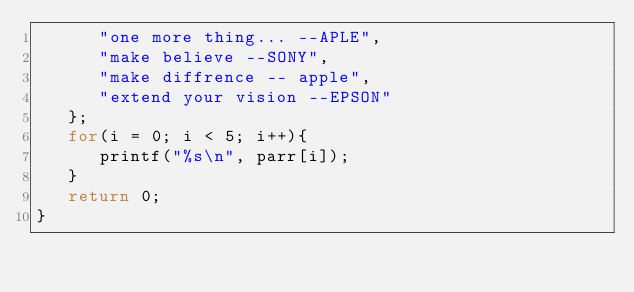<code> <loc_0><loc_0><loc_500><loc_500><_C_>      "one more thing... --APLE",
      "make believe --SONY",
      "make diffrence -- apple",
      "extend your vision --EPSON"
   };
   for(i = 0; i < 5; i++){
      printf("%s\n", parr[i]);
   }
   return 0;
}
</code> 